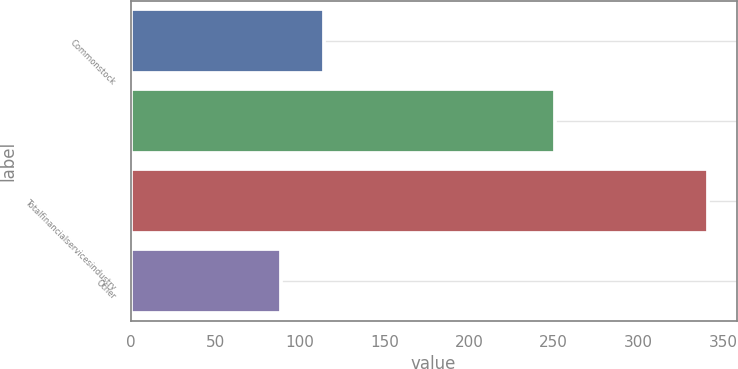Convert chart. <chart><loc_0><loc_0><loc_500><loc_500><bar_chart><fcel>Commonstock<fcel>Unnamed: 1<fcel>Totalfinancialservicesindustry<fcel>Other<nl><fcel>114.2<fcel>251<fcel>341<fcel>89<nl></chart> 